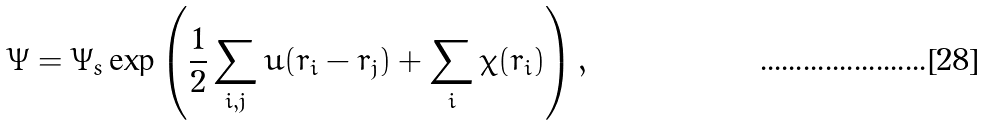Convert formula to latex. <formula><loc_0><loc_0><loc_500><loc_500>\Psi = \Psi _ { s } \exp \left ( \frac { 1 } { 2 } \sum _ { i , j } u ( { r } _ { i } - { r } _ { j } ) + \sum _ { i } \chi ( { r } _ { i } ) \right ) ,</formula> 